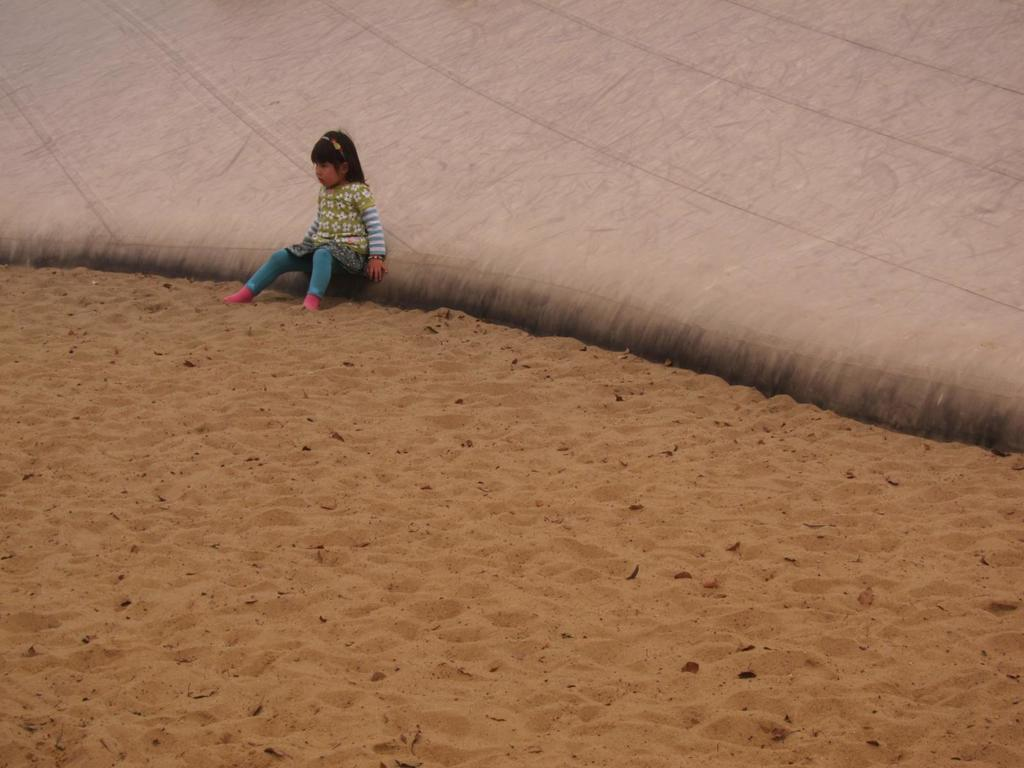What is the main subject of the picture? The main subject of the picture is a child. What is the child wearing? The child is wearing a dress. Where is the child sitting? The child is sitting on a white surface. What type of environment is visible in the image? There is sand visible in the image. What type of room is the child in, and what is the temperature? There is no room visible in the image, and the temperature cannot be determined from the image. 